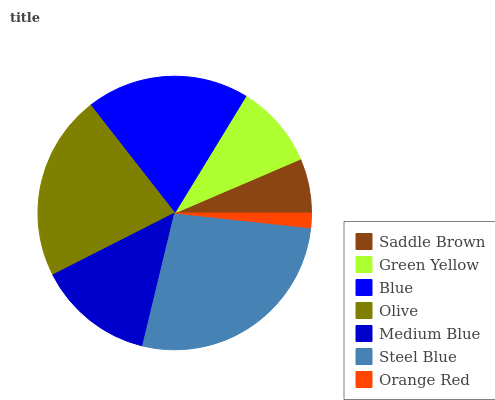Is Orange Red the minimum?
Answer yes or no. Yes. Is Steel Blue the maximum?
Answer yes or no. Yes. Is Green Yellow the minimum?
Answer yes or no. No. Is Green Yellow the maximum?
Answer yes or no. No. Is Green Yellow greater than Saddle Brown?
Answer yes or no. Yes. Is Saddle Brown less than Green Yellow?
Answer yes or no. Yes. Is Saddle Brown greater than Green Yellow?
Answer yes or no. No. Is Green Yellow less than Saddle Brown?
Answer yes or no. No. Is Medium Blue the high median?
Answer yes or no. Yes. Is Medium Blue the low median?
Answer yes or no. Yes. Is Steel Blue the high median?
Answer yes or no. No. Is Saddle Brown the low median?
Answer yes or no. No. 